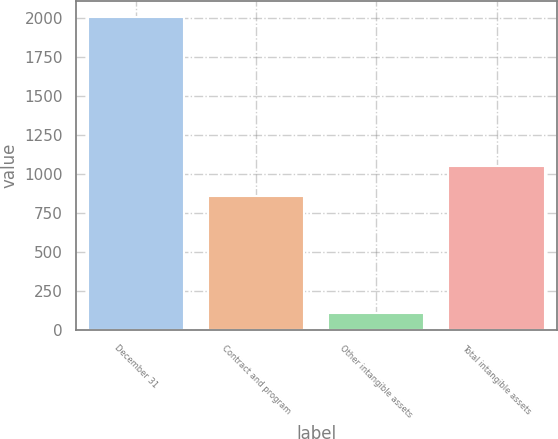Convert chart to OTSL. <chart><loc_0><loc_0><loc_500><loc_500><bar_chart><fcel>December 31<fcel>Contract and program<fcel>Other intangible assets<fcel>Total intangible assets<nl><fcel>2007<fcel>862<fcel>110<fcel>1051.7<nl></chart> 